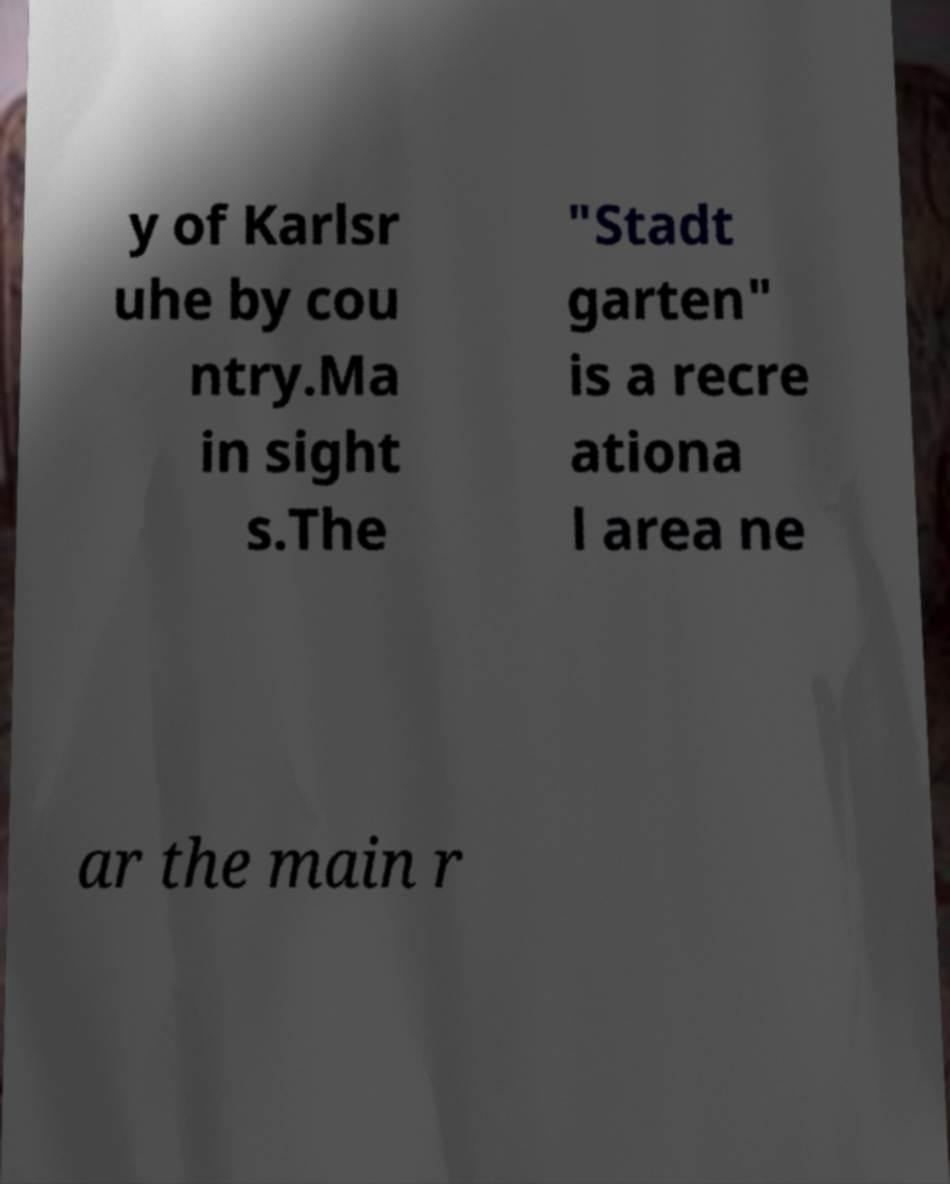What messages or text are displayed in this image? I need them in a readable, typed format. y of Karlsr uhe by cou ntry.Ma in sight s.The "Stadt garten" is a recre ationa l area ne ar the main r 